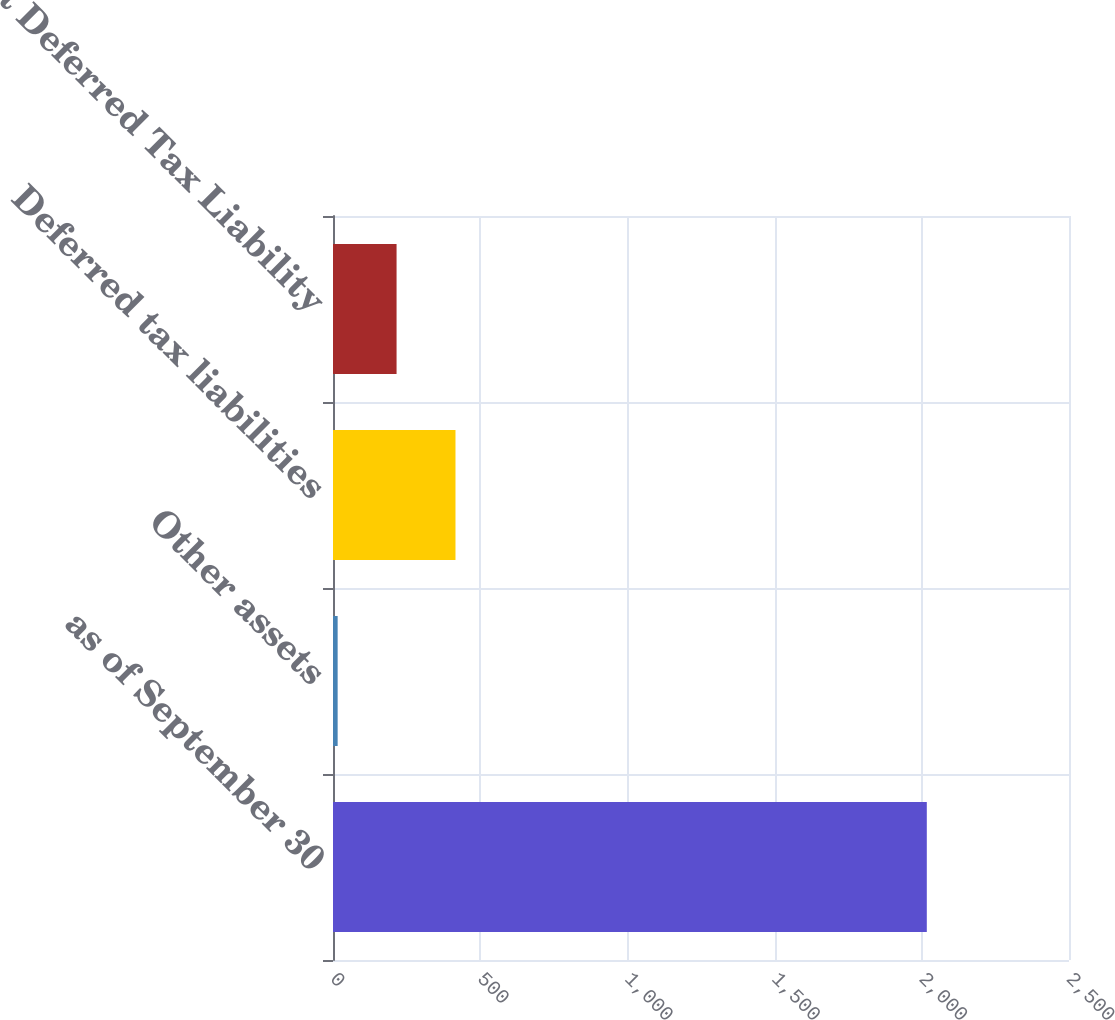Convert chart. <chart><loc_0><loc_0><loc_500><loc_500><bar_chart><fcel>as of September 30<fcel>Other assets<fcel>Deferred tax liabilities<fcel>Net Deferred Tax Liability<nl><fcel>2017<fcel>15.8<fcel>416.04<fcel>215.92<nl></chart> 